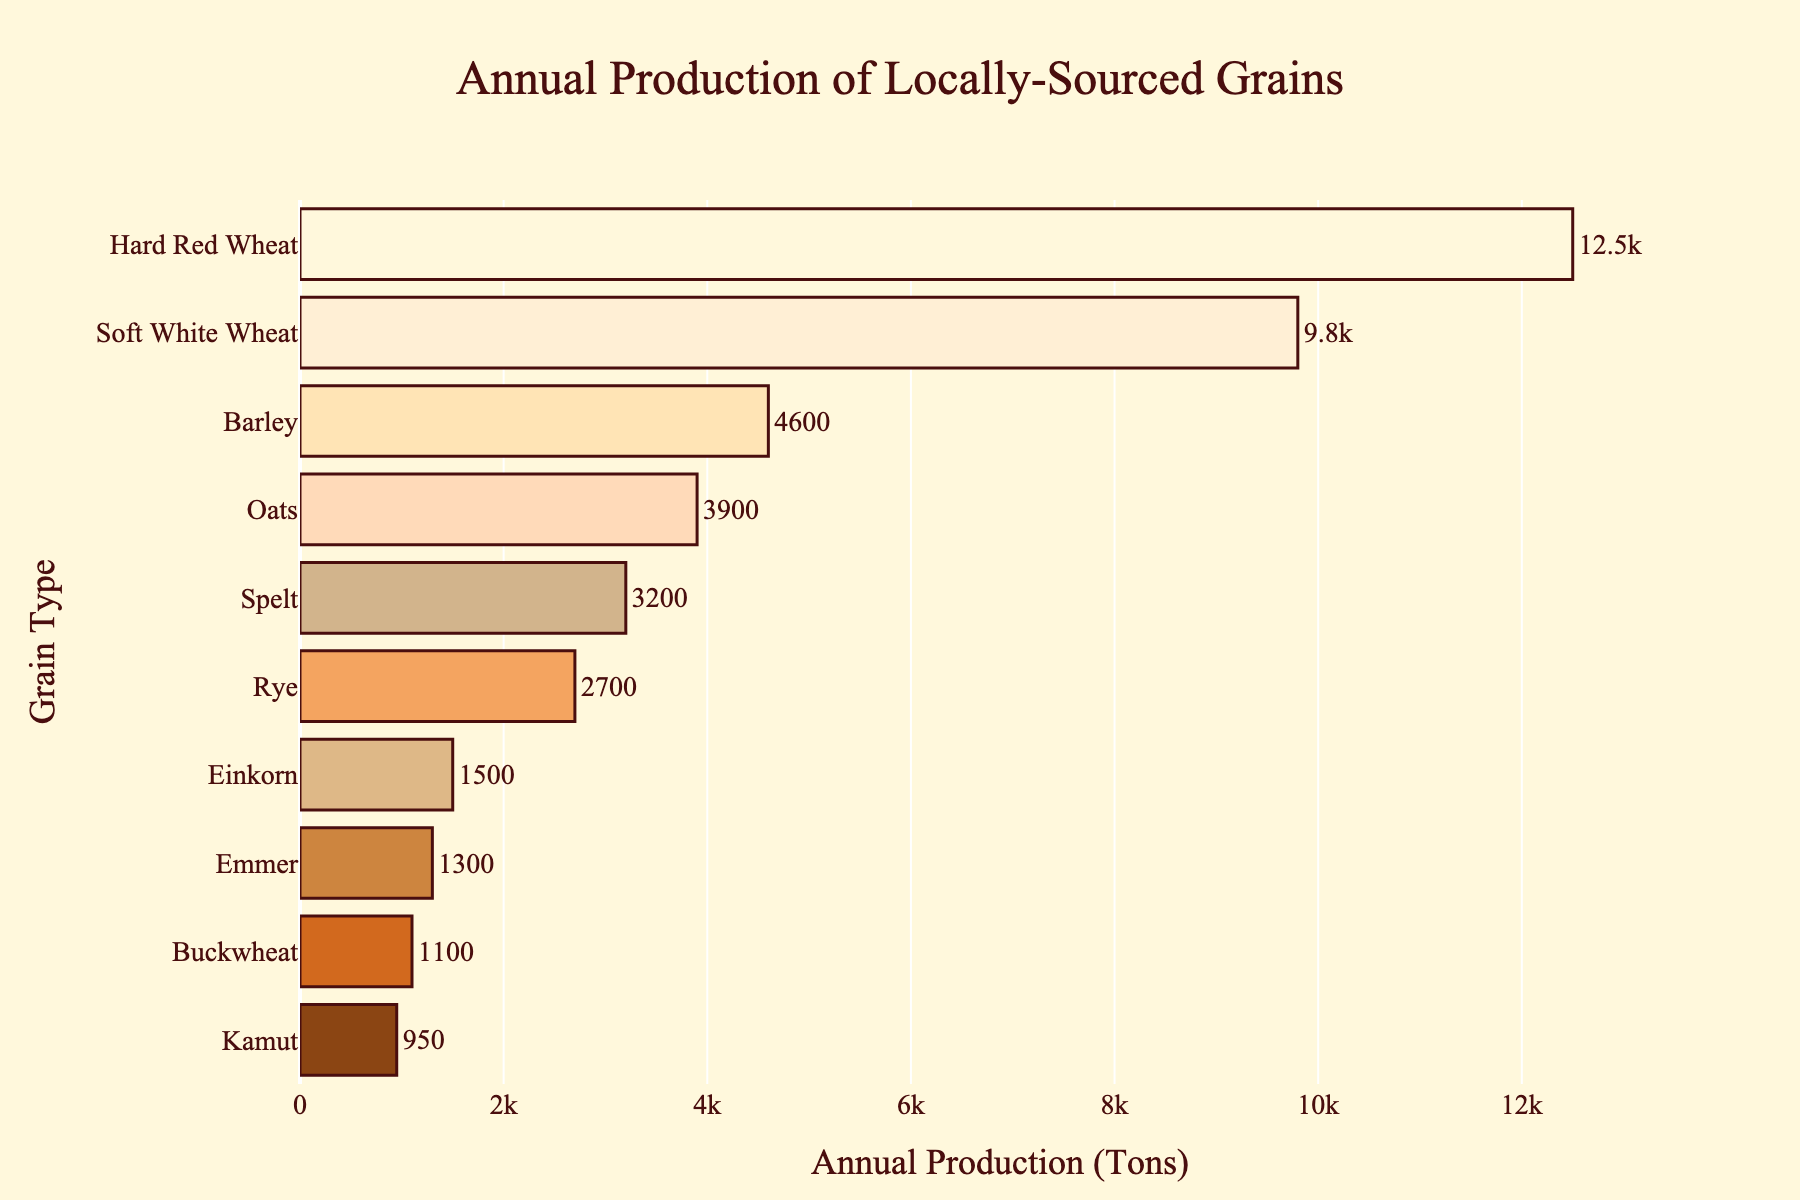Which grain has the highest annual production volume? The bar chart shows the production volumes of different grains, with the longest bar representing the highest volume. The longest bar corresponds to Hard Red Wheat.
Answer: Hard Red Wheat Which grain has the lowest annual production volume? The shortest bar in the chart indicates the lowest annual production volume. The shortest bar corresponds to Kamut.
Answer: Kamut How much more Hard Red Wheat is produced annually compared to Rye? The production volume of Hard Red Wheat is 12500 tons and for Rye it is 2700 tons. The difference is 12500 - 2700 = 9800 tons.
Answer: 9800 tons What is the combined annual production volume of Emmer and Buckwheat? The annual production volume for Emmer is 1300 tons and for Buckwheat it is 1100 tons. The combined volume is 1300 + 1100 = 2400 tons.
Answer: 2400 tons Between Barley and Oats, which grain has a higher annual production volume? The bar for Barley is longer than the bar for Oats. Therefore, Barley has a higher annual production volume than Oats.
Answer: Barley Which grain types have an annual production volume less than 2000 tons? By looking at the bars that are shorter and within the range under 2000 tons, we identify Einkorn, Emmer, Kamut, and Buckwheat as having less than 2000 tons of annual production.
Answer: Einkorn, Emmer, Kamut, and Buckwheat What is the sum of the annual production volumes for Soft White Wheat, Spelt, and Barley? The annual production for Soft White Wheat is 9800 tons, for Spelt is 3200 tons, and for Barley is 4600 tons. The sum is 9800 + 3200 + 4600 = 17600 tons.
Answer: 17600 tons Which grain has the third highest annual production volume? The bar chart shows the grains arranged by production volume. The third longest bar corresponds to Barley.
Answer: Barley How does the annual production of Soft White Wheat compare to Hard Red Wheat? The bar for Hard Red Wheat is longer than the bar for Soft White Wheat, indicating that Hard Red Wheat has a higher annual production volume.
Answer: Hard Red Wheat produces more Which two grains are closest in annual production volume, and what is their difference? By comparing the lengths of the bars, Emmer and Buckwheat are closest in production volume. Emmer has 1300 tons and Buckwheat has 1100 tons. The difference is 1300 - 1100 = 200 tons.
Answer: Emmer and Buckwheat, 200 tons 